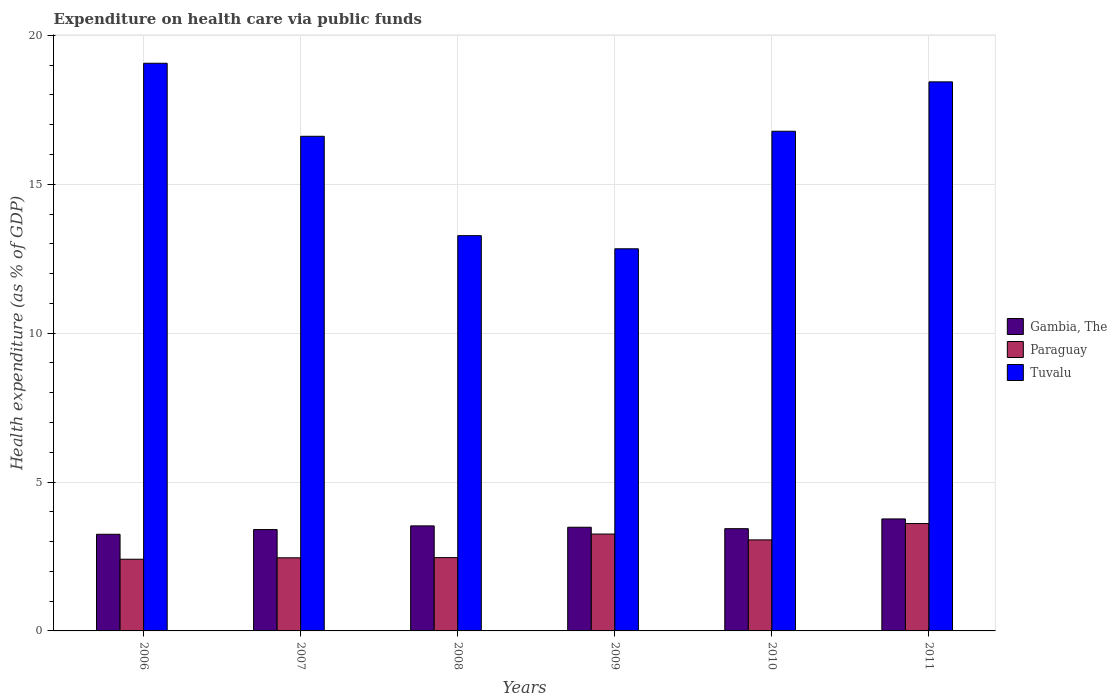How many different coloured bars are there?
Give a very brief answer. 3. How many groups of bars are there?
Offer a very short reply. 6. Are the number of bars on each tick of the X-axis equal?
Ensure brevity in your answer.  Yes. How many bars are there on the 3rd tick from the left?
Your response must be concise. 3. What is the label of the 4th group of bars from the left?
Keep it short and to the point. 2009. In how many cases, is the number of bars for a given year not equal to the number of legend labels?
Give a very brief answer. 0. What is the expenditure made on health care in Tuvalu in 2006?
Keep it short and to the point. 19.06. Across all years, what is the maximum expenditure made on health care in Gambia, The?
Your answer should be very brief. 3.76. Across all years, what is the minimum expenditure made on health care in Tuvalu?
Make the answer very short. 12.83. In which year was the expenditure made on health care in Gambia, The maximum?
Offer a very short reply. 2011. What is the total expenditure made on health care in Gambia, The in the graph?
Offer a terse response. 20.85. What is the difference between the expenditure made on health care in Tuvalu in 2006 and that in 2010?
Your response must be concise. 2.28. What is the difference between the expenditure made on health care in Tuvalu in 2008 and the expenditure made on health care in Gambia, The in 2007?
Provide a short and direct response. 9.87. What is the average expenditure made on health care in Gambia, The per year?
Your answer should be compact. 3.48. In the year 2010, what is the difference between the expenditure made on health care in Paraguay and expenditure made on health care in Tuvalu?
Offer a very short reply. -13.72. What is the ratio of the expenditure made on health care in Paraguay in 2007 to that in 2011?
Give a very brief answer. 0.68. Is the difference between the expenditure made on health care in Paraguay in 2008 and 2009 greater than the difference between the expenditure made on health care in Tuvalu in 2008 and 2009?
Keep it short and to the point. No. What is the difference between the highest and the second highest expenditure made on health care in Paraguay?
Offer a very short reply. 0.35. What is the difference between the highest and the lowest expenditure made on health care in Paraguay?
Offer a terse response. 1.2. In how many years, is the expenditure made on health care in Tuvalu greater than the average expenditure made on health care in Tuvalu taken over all years?
Keep it short and to the point. 4. What does the 1st bar from the left in 2009 represents?
Your answer should be very brief. Gambia, The. What does the 1st bar from the right in 2008 represents?
Provide a succinct answer. Tuvalu. How many bars are there?
Your answer should be compact. 18. What is the difference between two consecutive major ticks on the Y-axis?
Offer a very short reply. 5. Are the values on the major ticks of Y-axis written in scientific E-notation?
Your answer should be very brief. No. Does the graph contain any zero values?
Provide a short and direct response. No. How many legend labels are there?
Offer a very short reply. 3. What is the title of the graph?
Keep it short and to the point. Expenditure on health care via public funds. What is the label or title of the X-axis?
Your answer should be very brief. Years. What is the label or title of the Y-axis?
Ensure brevity in your answer.  Health expenditure (as % of GDP). What is the Health expenditure (as % of GDP) in Gambia, The in 2006?
Make the answer very short. 3.25. What is the Health expenditure (as % of GDP) in Paraguay in 2006?
Give a very brief answer. 2.41. What is the Health expenditure (as % of GDP) of Tuvalu in 2006?
Keep it short and to the point. 19.06. What is the Health expenditure (as % of GDP) of Gambia, The in 2007?
Your response must be concise. 3.4. What is the Health expenditure (as % of GDP) of Paraguay in 2007?
Your answer should be compact. 2.46. What is the Health expenditure (as % of GDP) of Tuvalu in 2007?
Keep it short and to the point. 16.61. What is the Health expenditure (as % of GDP) of Gambia, The in 2008?
Provide a short and direct response. 3.53. What is the Health expenditure (as % of GDP) in Paraguay in 2008?
Make the answer very short. 2.46. What is the Health expenditure (as % of GDP) in Tuvalu in 2008?
Your response must be concise. 13.27. What is the Health expenditure (as % of GDP) in Gambia, The in 2009?
Offer a terse response. 3.48. What is the Health expenditure (as % of GDP) of Paraguay in 2009?
Offer a terse response. 3.25. What is the Health expenditure (as % of GDP) in Tuvalu in 2009?
Give a very brief answer. 12.83. What is the Health expenditure (as % of GDP) of Gambia, The in 2010?
Offer a terse response. 3.43. What is the Health expenditure (as % of GDP) in Paraguay in 2010?
Offer a terse response. 3.06. What is the Health expenditure (as % of GDP) in Tuvalu in 2010?
Make the answer very short. 16.78. What is the Health expenditure (as % of GDP) of Gambia, The in 2011?
Ensure brevity in your answer.  3.76. What is the Health expenditure (as % of GDP) in Paraguay in 2011?
Your answer should be compact. 3.61. What is the Health expenditure (as % of GDP) in Tuvalu in 2011?
Your answer should be very brief. 18.44. Across all years, what is the maximum Health expenditure (as % of GDP) of Gambia, The?
Your response must be concise. 3.76. Across all years, what is the maximum Health expenditure (as % of GDP) of Paraguay?
Ensure brevity in your answer.  3.61. Across all years, what is the maximum Health expenditure (as % of GDP) in Tuvalu?
Ensure brevity in your answer.  19.06. Across all years, what is the minimum Health expenditure (as % of GDP) in Gambia, The?
Offer a very short reply. 3.25. Across all years, what is the minimum Health expenditure (as % of GDP) in Paraguay?
Your answer should be compact. 2.41. Across all years, what is the minimum Health expenditure (as % of GDP) in Tuvalu?
Provide a short and direct response. 12.83. What is the total Health expenditure (as % of GDP) in Gambia, The in the graph?
Make the answer very short. 20.85. What is the total Health expenditure (as % of GDP) in Paraguay in the graph?
Your response must be concise. 17.24. What is the total Health expenditure (as % of GDP) in Tuvalu in the graph?
Provide a succinct answer. 97. What is the difference between the Health expenditure (as % of GDP) of Gambia, The in 2006 and that in 2007?
Your response must be concise. -0.16. What is the difference between the Health expenditure (as % of GDP) of Paraguay in 2006 and that in 2007?
Give a very brief answer. -0.05. What is the difference between the Health expenditure (as % of GDP) in Tuvalu in 2006 and that in 2007?
Offer a terse response. 2.45. What is the difference between the Health expenditure (as % of GDP) of Gambia, The in 2006 and that in 2008?
Provide a short and direct response. -0.28. What is the difference between the Health expenditure (as % of GDP) of Paraguay in 2006 and that in 2008?
Make the answer very short. -0.05. What is the difference between the Health expenditure (as % of GDP) in Tuvalu in 2006 and that in 2008?
Your answer should be very brief. 5.79. What is the difference between the Health expenditure (as % of GDP) in Gambia, The in 2006 and that in 2009?
Ensure brevity in your answer.  -0.24. What is the difference between the Health expenditure (as % of GDP) in Paraguay in 2006 and that in 2009?
Your response must be concise. -0.85. What is the difference between the Health expenditure (as % of GDP) in Tuvalu in 2006 and that in 2009?
Provide a short and direct response. 6.23. What is the difference between the Health expenditure (as % of GDP) in Gambia, The in 2006 and that in 2010?
Provide a short and direct response. -0.19. What is the difference between the Health expenditure (as % of GDP) of Paraguay in 2006 and that in 2010?
Offer a terse response. -0.65. What is the difference between the Health expenditure (as % of GDP) in Tuvalu in 2006 and that in 2010?
Keep it short and to the point. 2.28. What is the difference between the Health expenditure (as % of GDP) in Gambia, The in 2006 and that in 2011?
Your answer should be very brief. -0.52. What is the difference between the Health expenditure (as % of GDP) of Paraguay in 2006 and that in 2011?
Make the answer very short. -1.2. What is the difference between the Health expenditure (as % of GDP) of Tuvalu in 2006 and that in 2011?
Offer a very short reply. 0.62. What is the difference between the Health expenditure (as % of GDP) in Gambia, The in 2007 and that in 2008?
Offer a terse response. -0.12. What is the difference between the Health expenditure (as % of GDP) of Paraguay in 2007 and that in 2008?
Your answer should be very brief. -0.01. What is the difference between the Health expenditure (as % of GDP) in Tuvalu in 2007 and that in 2008?
Provide a short and direct response. 3.34. What is the difference between the Health expenditure (as % of GDP) in Gambia, The in 2007 and that in 2009?
Your answer should be very brief. -0.08. What is the difference between the Health expenditure (as % of GDP) in Paraguay in 2007 and that in 2009?
Your answer should be very brief. -0.8. What is the difference between the Health expenditure (as % of GDP) in Tuvalu in 2007 and that in 2009?
Offer a very short reply. 3.78. What is the difference between the Health expenditure (as % of GDP) of Gambia, The in 2007 and that in 2010?
Offer a terse response. -0.03. What is the difference between the Health expenditure (as % of GDP) in Paraguay in 2007 and that in 2010?
Ensure brevity in your answer.  -0.6. What is the difference between the Health expenditure (as % of GDP) of Tuvalu in 2007 and that in 2010?
Offer a terse response. -0.17. What is the difference between the Health expenditure (as % of GDP) of Gambia, The in 2007 and that in 2011?
Make the answer very short. -0.36. What is the difference between the Health expenditure (as % of GDP) in Paraguay in 2007 and that in 2011?
Your answer should be compact. -1.15. What is the difference between the Health expenditure (as % of GDP) of Tuvalu in 2007 and that in 2011?
Ensure brevity in your answer.  -1.83. What is the difference between the Health expenditure (as % of GDP) in Gambia, The in 2008 and that in 2009?
Keep it short and to the point. 0.05. What is the difference between the Health expenditure (as % of GDP) of Paraguay in 2008 and that in 2009?
Your response must be concise. -0.79. What is the difference between the Health expenditure (as % of GDP) of Tuvalu in 2008 and that in 2009?
Provide a succinct answer. 0.44. What is the difference between the Health expenditure (as % of GDP) in Gambia, The in 2008 and that in 2010?
Offer a very short reply. 0.09. What is the difference between the Health expenditure (as % of GDP) of Paraguay in 2008 and that in 2010?
Your response must be concise. -0.6. What is the difference between the Health expenditure (as % of GDP) of Tuvalu in 2008 and that in 2010?
Your response must be concise. -3.51. What is the difference between the Health expenditure (as % of GDP) in Gambia, The in 2008 and that in 2011?
Keep it short and to the point. -0.23. What is the difference between the Health expenditure (as % of GDP) in Paraguay in 2008 and that in 2011?
Keep it short and to the point. -1.14. What is the difference between the Health expenditure (as % of GDP) of Tuvalu in 2008 and that in 2011?
Ensure brevity in your answer.  -5.16. What is the difference between the Health expenditure (as % of GDP) in Gambia, The in 2009 and that in 2010?
Make the answer very short. 0.05. What is the difference between the Health expenditure (as % of GDP) in Paraguay in 2009 and that in 2010?
Provide a short and direct response. 0.2. What is the difference between the Health expenditure (as % of GDP) in Tuvalu in 2009 and that in 2010?
Provide a succinct answer. -3.95. What is the difference between the Health expenditure (as % of GDP) of Gambia, The in 2009 and that in 2011?
Your answer should be compact. -0.28. What is the difference between the Health expenditure (as % of GDP) in Paraguay in 2009 and that in 2011?
Offer a very short reply. -0.35. What is the difference between the Health expenditure (as % of GDP) in Tuvalu in 2009 and that in 2011?
Provide a succinct answer. -5.61. What is the difference between the Health expenditure (as % of GDP) of Gambia, The in 2010 and that in 2011?
Offer a terse response. -0.33. What is the difference between the Health expenditure (as % of GDP) of Paraguay in 2010 and that in 2011?
Your response must be concise. -0.55. What is the difference between the Health expenditure (as % of GDP) in Tuvalu in 2010 and that in 2011?
Keep it short and to the point. -1.66. What is the difference between the Health expenditure (as % of GDP) of Gambia, The in 2006 and the Health expenditure (as % of GDP) of Paraguay in 2007?
Your response must be concise. 0.79. What is the difference between the Health expenditure (as % of GDP) of Gambia, The in 2006 and the Health expenditure (as % of GDP) of Tuvalu in 2007?
Your response must be concise. -13.36. What is the difference between the Health expenditure (as % of GDP) in Paraguay in 2006 and the Health expenditure (as % of GDP) in Tuvalu in 2007?
Offer a very short reply. -14.2. What is the difference between the Health expenditure (as % of GDP) of Gambia, The in 2006 and the Health expenditure (as % of GDP) of Paraguay in 2008?
Offer a terse response. 0.78. What is the difference between the Health expenditure (as % of GDP) of Gambia, The in 2006 and the Health expenditure (as % of GDP) of Tuvalu in 2008?
Offer a very short reply. -10.03. What is the difference between the Health expenditure (as % of GDP) of Paraguay in 2006 and the Health expenditure (as % of GDP) of Tuvalu in 2008?
Your answer should be very brief. -10.87. What is the difference between the Health expenditure (as % of GDP) in Gambia, The in 2006 and the Health expenditure (as % of GDP) in Paraguay in 2009?
Your answer should be very brief. -0.01. What is the difference between the Health expenditure (as % of GDP) of Gambia, The in 2006 and the Health expenditure (as % of GDP) of Tuvalu in 2009?
Offer a very short reply. -9.59. What is the difference between the Health expenditure (as % of GDP) in Paraguay in 2006 and the Health expenditure (as % of GDP) in Tuvalu in 2009?
Keep it short and to the point. -10.43. What is the difference between the Health expenditure (as % of GDP) of Gambia, The in 2006 and the Health expenditure (as % of GDP) of Paraguay in 2010?
Ensure brevity in your answer.  0.19. What is the difference between the Health expenditure (as % of GDP) in Gambia, The in 2006 and the Health expenditure (as % of GDP) in Tuvalu in 2010?
Your response must be concise. -13.53. What is the difference between the Health expenditure (as % of GDP) in Paraguay in 2006 and the Health expenditure (as % of GDP) in Tuvalu in 2010?
Your answer should be compact. -14.37. What is the difference between the Health expenditure (as % of GDP) of Gambia, The in 2006 and the Health expenditure (as % of GDP) of Paraguay in 2011?
Provide a short and direct response. -0.36. What is the difference between the Health expenditure (as % of GDP) of Gambia, The in 2006 and the Health expenditure (as % of GDP) of Tuvalu in 2011?
Offer a very short reply. -15.19. What is the difference between the Health expenditure (as % of GDP) in Paraguay in 2006 and the Health expenditure (as % of GDP) in Tuvalu in 2011?
Make the answer very short. -16.03. What is the difference between the Health expenditure (as % of GDP) of Gambia, The in 2007 and the Health expenditure (as % of GDP) of Paraguay in 2008?
Offer a terse response. 0.94. What is the difference between the Health expenditure (as % of GDP) in Gambia, The in 2007 and the Health expenditure (as % of GDP) in Tuvalu in 2008?
Offer a very short reply. -9.87. What is the difference between the Health expenditure (as % of GDP) in Paraguay in 2007 and the Health expenditure (as % of GDP) in Tuvalu in 2008?
Give a very brief answer. -10.82. What is the difference between the Health expenditure (as % of GDP) of Gambia, The in 2007 and the Health expenditure (as % of GDP) of Paraguay in 2009?
Your answer should be very brief. 0.15. What is the difference between the Health expenditure (as % of GDP) in Gambia, The in 2007 and the Health expenditure (as % of GDP) in Tuvalu in 2009?
Your answer should be compact. -9.43. What is the difference between the Health expenditure (as % of GDP) in Paraguay in 2007 and the Health expenditure (as % of GDP) in Tuvalu in 2009?
Your answer should be very brief. -10.38. What is the difference between the Health expenditure (as % of GDP) in Gambia, The in 2007 and the Health expenditure (as % of GDP) in Paraguay in 2010?
Your answer should be very brief. 0.35. What is the difference between the Health expenditure (as % of GDP) of Gambia, The in 2007 and the Health expenditure (as % of GDP) of Tuvalu in 2010?
Offer a very short reply. -13.38. What is the difference between the Health expenditure (as % of GDP) of Paraguay in 2007 and the Health expenditure (as % of GDP) of Tuvalu in 2010?
Your answer should be very brief. -14.32. What is the difference between the Health expenditure (as % of GDP) in Gambia, The in 2007 and the Health expenditure (as % of GDP) in Paraguay in 2011?
Your response must be concise. -0.2. What is the difference between the Health expenditure (as % of GDP) in Gambia, The in 2007 and the Health expenditure (as % of GDP) in Tuvalu in 2011?
Ensure brevity in your answer.  -15.03. What is the difference between the Health expenditure (as % of GDP) of Paraguay in 2007 and the Health expenditure (as % of GDP) of Tuvalu in 2011?
Ensure brevity in your answer.  -15.98. What is the difference between the Health expenditure (as % of GDP) of Gambia, The in 2008 and the Health expenditure (as % of GDP) of Paraguay in 2009?
Your response must be concise. 0.27. What is the difference between the Health expenditure (as % of GDP) in Gambia, The in 2008 and the Health expenditure (as % of GDP) in Tuvalu in 2009?
Your response must be concise. -9.3. What is the difference between the Health expenditure (as % of GDP) in Paraguay in 2008 and the Health expenditure (as % of GDP) in Tuvalu in 2009?
Your answer should be very brief. -10.37. What is the difference between the Health expenditure (as % of GDP) in Gambia, The in 2008 and the Health expenditure (as % of GDP) in Paraguay in 2010?
Ensure brevity in your answer.  0.47. What is the difference between the Health expenditure (as % of GDP) of Gambia, The in 2008 and the Health expenditure (as % of GDP) of Tuvalu in 2010?
Offer a very short reply. -13.25. What is the difference between the Health expenditure (as % of GDP) of Paraguay in 2008 and the Health expenditure (as % of GDP) of Tuvalu in 2010?
Your answer should be very brief. -14.32. What is the difference between the Health expenditure (as % of GDP) of Gambia, The in 2008 and the Health expenditure (as % of GDP) of Paraguay in 2011?
Your answer should be compact. -0.08. What is the difference between the Health expenditure (as % of GDP) of Gambia, The in 2008 and the Health expenditure (as % of GDP) of Tuvalu in 2011?
Provide a short and direct response. -14.91. What is the difference between the Health expenditure (as % of GDP) of Paraguay in 2008 and the Health expenditure (as % of GDP) of Tuvalu in 2011?
Keep it short and to the point. -15.98. What is the difference between the Health expenditure (as % of GDP) of Gambia, The in 2009 and the Health expenditure (as % of GDP) of Paraguay in 2010?
Make the answer very short. 0.42. What is the difference between the Health expenditure (as % of GDP) of Gambia, The in 2009 and the Health expenditure (as % of GDP) of Tuvalu in 2010?
Make the answer very short. -13.3. What is the difference between the Health expenditure (as % of GDP) in Paraguay in 2009 and the Health expenditure (as % of GDP) in Tuvalu in 2010?
Make the answer very short. -13.53. What is the difference between the Health expenditure (as % of GDP) of Gambia, The in 2009 and the Health expenditure (as % of GDP) of Paraguay in 2011?
Offer a terse response. -0.12. What is the difference between the Health expenditure (as % of GDP) in Gambia, The in 2009 and the Health expenditure (as % of GDP) in Tuvalu in 2011?
Your answer should be very brief. -14.96. What is the difference between the Health expenditure (as % of GDP) in Paraguay in 2009 and the Health expenditure (as % of GDP) in Tuvalu in 2011?
Provide a short and direct response. -15.18. What is the difference between the Health expenditure (as % of GDP) of Gambia, The in 2010 and the Health expenditure (as % of GDP) of Paraguay in 2011?
Your answer should be compact. -0.17. What is the difference between the Health expenditure (as % of GDP) of Gambia, The in 2010 and the Health expenditure (as % of GDP) of Tuvalu in 2011?
Keep it short and to the point. -15. What is the difference between the Health expenditure (as % of GDP) of Paraguay in 2010 and the Health expenditure (as % of GDP) of Tuvalu in 2011?
Make the answer very short. -15.38. What is the average Health expenditure (as % of GDP) in Gambia, The per year?
Offer a very short reply. 3.48. What is the average Health expenditure (as % of GDP) in Paraguay per year?
Offer a terse response. 2.87. What is the average Health expenditure (as % of GDP) of Tuvalu per year?
Give a very brief answer. 16.17. In the year 2006, what is the difference between the Health expenditure (as % of GDP) of Gambia, The and Health expenditure (as % of GDP) of Paraguay?
Offer a very short reply. 0.84. In the year 2006, what is the difference between the Health expenditure (as % of GDP) in Gambia, The and Health expenditure (as % of GDP) in Tuvalu?
Offer a terse response. -15.82. In the year 2006, what is the difference between the Health expenditure (as % of GDP) of Paraguay and Health expenditure (as % of GDP) of Tuvalu?
Provide a short and direct response. -16.66. In the year 2007, what is the difference between the Health expenditure (as % of GDP) of Gambia, The and Health expenditure (as % of GDP) of Paraguay?
Provide a succinct answer. 0.95. In the year 2007, what is the difference between the Health expenditure (as % of GDP) of Gambia, The and Health expenditure (as % of GDP) of Tuvalu?
Your response must be concise. -13.21. In the year 2007, what is the difference between the Health expenditure (as % of GDP) in Paraguay and Health expenditure (as % of GDP) in Tuvalu?
Offer a very short reply. -14.15. In the year 2008, what is the difference between the Health expenditure (as % of GDP) of Gambia, The and Health expenditure (as % of GDP) of Paraguay?
Offer a terse response. 1.07. In the year 2008, what is the difference between the Health expenditure (as % of GDP) in Gambia, The and Health expenditure (as % of GDP) in Tuvalu?
Give a very brief answer. -9.75. In the year 2008, what is the difference between the Health expenditure (as % of GDP) in Paraguay and Health expenditure (as % of GDP) in Tuvalu?
Your response must be concise. -10.81. In the year 2009, what is the difference between the Health expenditure (as % of GDP) in Gambia, The and Health expenditure (as % of GDP) in Paraguay?
Provide a short and direct response. 0.23. In the year 2009, what is the difference between the Health expenditure (as % of GDP) in Gambia, The and Health expenditure (as % of GDP) in Tuvalu?
Keep it short and to the point. -9.35. In the year 2009, what is the difference between the Health expenditure (as % of GDP) of Paraguay and Health expenditure (as % of GDP) of Tuvalu?
Ensure brevity in your answer.  -9.58. In the year 2010, what is the difference between the Health expenditure (as % of GDP) of Gambia, The and Health expenditure (as % of GDP) of Paraguay?
Keep it short and to the point. 0.38. In the year 2010, what is the difference between the Health expenditure (as % of GDP) in Gambia, The and Health expenditure (as % of GDP) in Tuvalu?
Offer a terse response. -13.35. In the year 2010, what is the difference between the Health expenditure (as % of GDP) of Paraguay and Health expenditure (as % of GDP) of Tuvalu?
Provide a short and direct response. -13.72. In the year 2011, what is the difference between the Health expenditure (as % of GDP) in Gambia, The and Health expenditure (as % of GDP) in Paraguay?
Make the answer very short. 0.16. In the year 2011, what is the difference between the Health expenditure (as % of GDP) in Gambia, The and Health expenditure (as % of GDP) in Tuvalu?
Your answer should be very brief. -14.68. In the year 2011, what is the difference between the Health expenditure (as % of GDP) in Paraguay and Health expenditure (as % of GDP) in Tuvalu?
Your response must be concise. -14.83. What is the ratio of the Health expenditure (as % of GDP) of Gambia, The in 2006 to that in 2007?
Keep it short and to the point. 0.95. What is the ratio of the Health expenditure (as % of GDP) in Paraguay in 2006 to that in 2007?
Make the answer very short. 0.98. What is the ratio of the Health expenditure (as % of GDP) of Tuvalu in 2006 to that in 2007?
Keep it short and to the point. 1.15. What is the ratio of the Health expenditure (as % of GDP) in Gambia, The in 2006 to that in 2008?
Offer a very short reply. 0.92. What is the ratio of the Health expenditure (as % of GDP) in Paraguay in 2006 to that in 2008?
Keep it short and to the point. 0.98. What is the ratio of the Health expenditure (as % of GDP) in Tuvalu in 2006 to that in 2008?
Your response must be concise. 1.44. What is the ratio of the Health expenditure (as % of GDP) of Gambia, The in 2006 to that in 2009?
Your answer should be compact. 0.93. What is the ratio of the Health expenditure (as % of GDP) in Paraguay in 2006 to that in 2009?
Offer a very short reply. 0.74. What is the ratio of the Health expenditure (as % of GDP) of Tuvalu in 2006 to that in 2009?
Your answer should be very brief. 1.49. What is the ratio of the Health expenditure (as % of GDP) of Gambia, The in 2006 to that in 2010?
Give a very brief answer. 0.95. What is the ratio of the Health expenditure (as % of GDP) in Paraguay in 2006 to that in 2010?
Provide a succinct answer. 0.79. What is the ratio of the Health expenditure (as % of GDP) of Tuvalu in 2006 to that in 2010?
Provide a short and direct response. 1.14. What is the ratio of the Health expenditure (as % of GDP) of Gambia, The in 2006 to that in 2011?
Offer a very short reply. 0.86. What is the ratio of the Health expenditure (as % of GDP) in Paraguay in 2006 to that in 2011?
Offer a very short reply. 0.67. What is the ratio of the Health expenditure (as % of GDP) of Tuvalu in 2006 to that in 2011?
Provide a short and direct response. 1.03. What is the ratio of the Health expenditure (as % of GDP) of Gambia, The in 2007 to that in 2008?
Provide a short and direct response. 0.96. What is the ratio of the Health expenditure (as % of GDP) in Paraguay in 2007 to that in 2008?
Provide a short and direct response. 1. What is the ratio of the Health expenditure (as % of GDP) in Tuvalu in 2007 to that in 2008?
Your response must be concise. 1.25. What is the ratio of the Health expenditure (as % of GDP) in Gambia, The in 2007 to that in 2009?
Ensure brevity in your answer.  0.98. What is the ratio of the Health expenditure (as % of GDP) in Paraguay in 2007 to that in 2009?
Offer a terse response. 0.75. What is the ratio of the Health expenditure (as % of GDP) in Tuvalu in 2007 to that in 2009?
Keep it short and to the point. 1.29. What is the ratio of the Health expenditure (as % of GDP) in Gambia, The in 2007 to that in 2010?
Give a very brief answer. 0.99. What is the ratio of the Health expenditure (as % of GDP) of Paraguay in 2007 to that in 2010?
Provide a short and direct response. 0.8. What is the ratio of the Health expenditure (as % of GDP) in Tuvalu in 2007 to that in 2010?
Offer a terse response. 0.99. What is the ratio of the Health expenditure (as % of GDP) in Gambia, The in 2007 to that in 2011?
Provide a short and direct response. 0.91. What is the ratio of the Health expenditure (as % of GDP) in Paraguay in 2007 to that in 2011?
Provide a succinct answer. 0.68. What is the ratio of the Health expenditure (as % of GDP) in Tuvalu in 2007 to that in 2011?
Your answer should be compact. 0.9. What is the ratio of the Health expenditure (as % of GDP) in Gambia, The in 2008 to that in 2009?
Ensure brevity in your answer.  1.01. What is the ratio of the Health expenditure (as % of GDP) in Paraguay in 2008 to that in 2009?
Ensure brevity in your answer.  0.76. What is the ratio of the Health expenditure (as % of GDP) of Tuvalu in 2008 to that in 2009?
Offer a terse response. 1.03. What is the ratio of the Health expenditure (as % of GDP) in Gambia, The in 2008 to that in 2010?
Make the answer very short. 1.03. What is the ratio of the Health expenditure (as % of GDP) of Paraguay in 2008 to that in 2010?
Keep it short and to the point. 0.81. What is the ratio of the Health expenditure (as % of GDP) in Tuvalu in 2008 to that in 2010?
Offer a very short reply. 0.79. What is the ratio of the Health expenditure (as % of GDP) in Gambia, The in 2008 to that in 2011?
Your answer should be very brief. 0.94. What is the ratio of the Health expenditure (as % of GDP) of Paraguay in 2008 to that in 2011?
Your answer should be compact. 0.68. What is the ratio of the Health expenditure (as % of GDP) of Tuvalu in 2008 to that in 2011?
Offer a terse response. 0.72. What is the ratio of the Health expenditure (as % of GDP) in Gambia, The in 2009 to that in 2010?
Your answer should be compact. 1.01. What is the ratio of the Health expenditure (as % of GDP) in Paraguay in 2009 to that in 2010?
Your answer should be compact. 1.06. What is the ratio of the Health expenditure (as % of GDP) in Tuvalu in 2009 to that in 2010?
Provide a succinct answer. 0.76. What is the ratio of the Health expenditure (as % of GDP) of Gambia, The in 2009 to that in 2011?
Keep it short and to the point. 0.93. What is the ratio of the Health expenditure (as % of GDP) in Paraguay in 2009 to that in 2011?
Offer a terse response. 0.9. What is the ratio of the Health expenditure (as % of GDP) in Tuvalu in 2009 to that in 2011?
Offer a very short reply. 0.7. What is the ratio of the Health expenditure (as % of GDP) of Paraguay in 2010 to that in 2011?
Offer a very short reply. 0.85. What is the ratio of the Health expenditure (as % of GDP) in Tuvalu in 2010 to that in 2011?
Ensure brevity in your answer.  0.91. What is the difference between the highest and the second highest Health expenditure (as % of GDP) of Gambia, The?
Provide a short and direct response. 0.23. What is the difference between the highest and the second highest Health expenditure (as % of GDP) of Paraguay?
Provide a succinct answer. 0.35. What is the difference between the highest and the second highest Health expenditure (as % of GDP) in Tuvalu?
Give a very brief answer. 0.62. What is the difference between the highest and the lowest Health expenditure (as % of GDP) in Gambia, The?
Your response must be concise. 0.52. What is the difference between the highest and the lowest Health expenditure (as % of GDP) of Paraguay?
Ensure brevity in your answer.  1.2. What is the difference between the highest and the lowest Health expenditure (as % of GDP) of Tuvalu?
Provide a succinct answer. 6.23. 